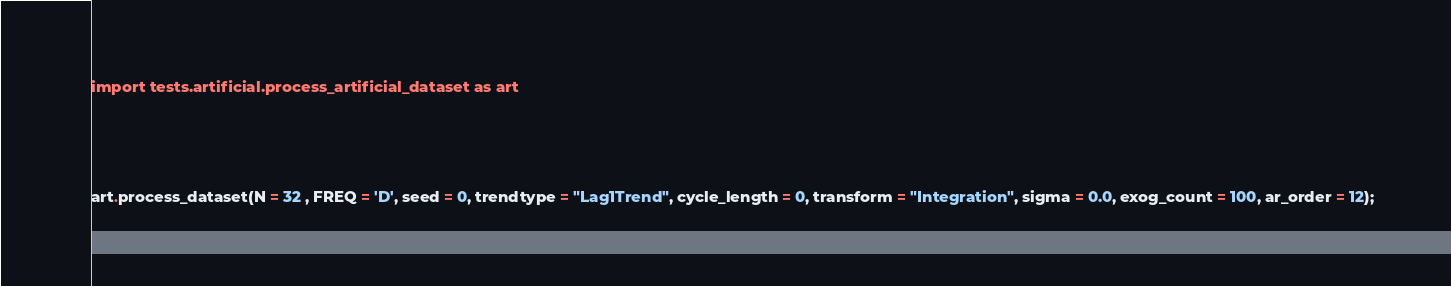<code> <loc_0><loc_0><loc_500><loc_500><_Python_>import tests.artificial.process_artificial_dataset as art




art.process_dataset(N = 32 , FREQ = 'D', seed = 0, trendtype = "Lag1Trend", cycle_length = 0, transform = "Integration", sigma = 0.0, exog_count = 100, ar_order = 12);</code> 